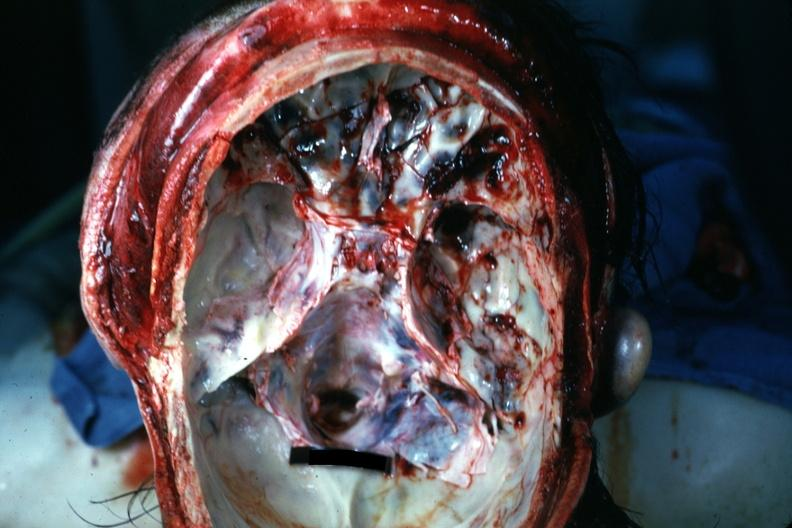what does this image show?
Answer the question using a single word or phrase. Opened cranial vault with many frontal and right temporal fossa fractures 